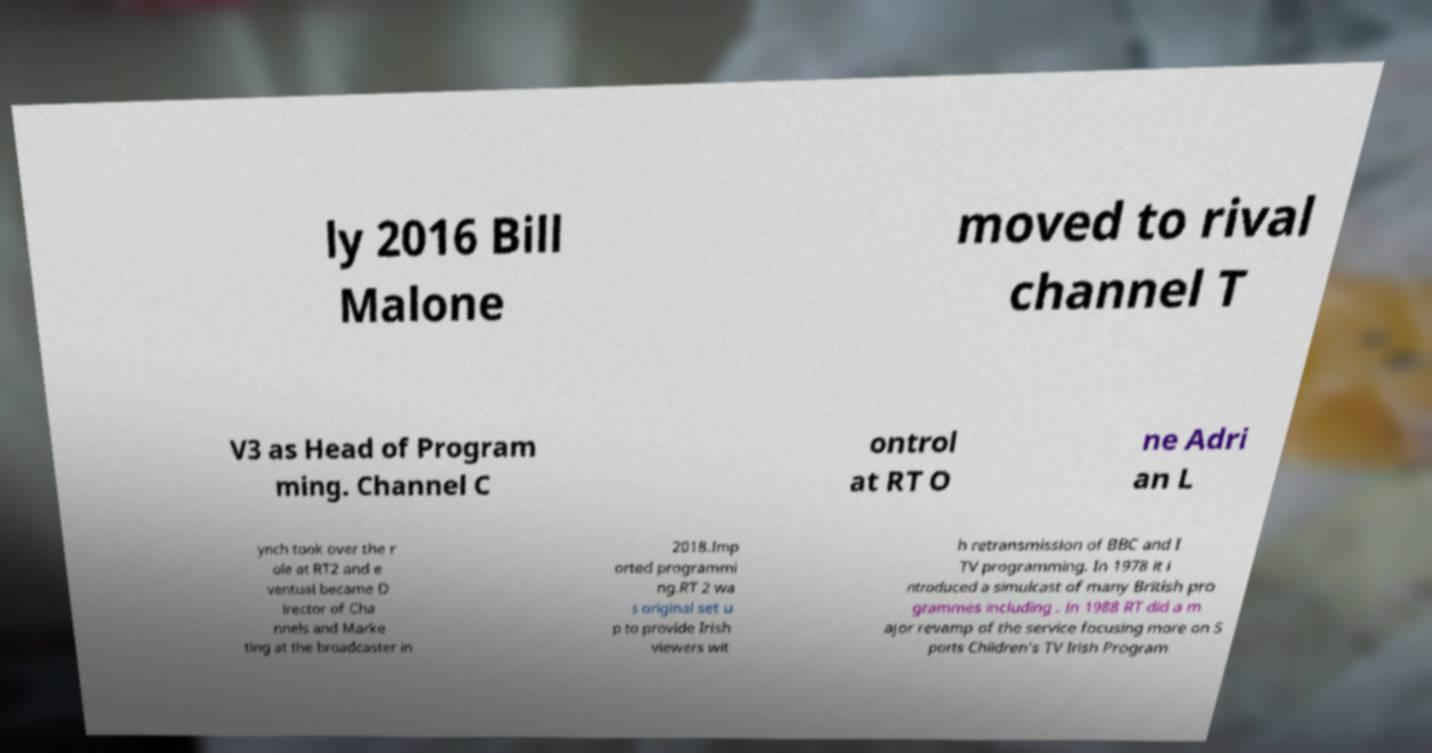For documentation purposes, I need the text within this image transcribed. Could you provide that? ly 2016 Bill Malone moved to rival channel T V3 as Head of Program ming. Channel C ontrol at RT O ne Adri an L ynch took over the r ole at RT2 and e ventual became D irector of Cha nnels and Marke ting at the broadcaster in 2018.Imp orted programmi ng.RT 2 wa s original set u p to provide Irish viewers wit h retransmission of BBC and I TV programming. In 1978 it i ntroduced a simulcast of many British pro grammes including . In 1988 RT did a m ajor revamp of the service focusing more on S ports Children's TV Irish Program 